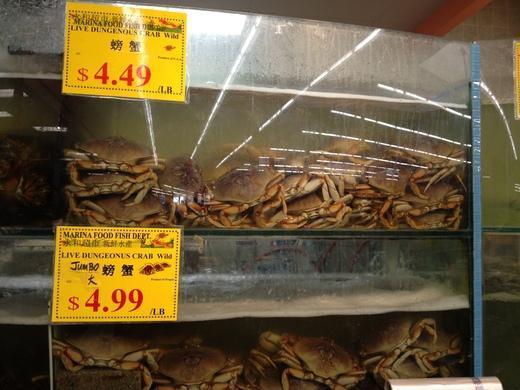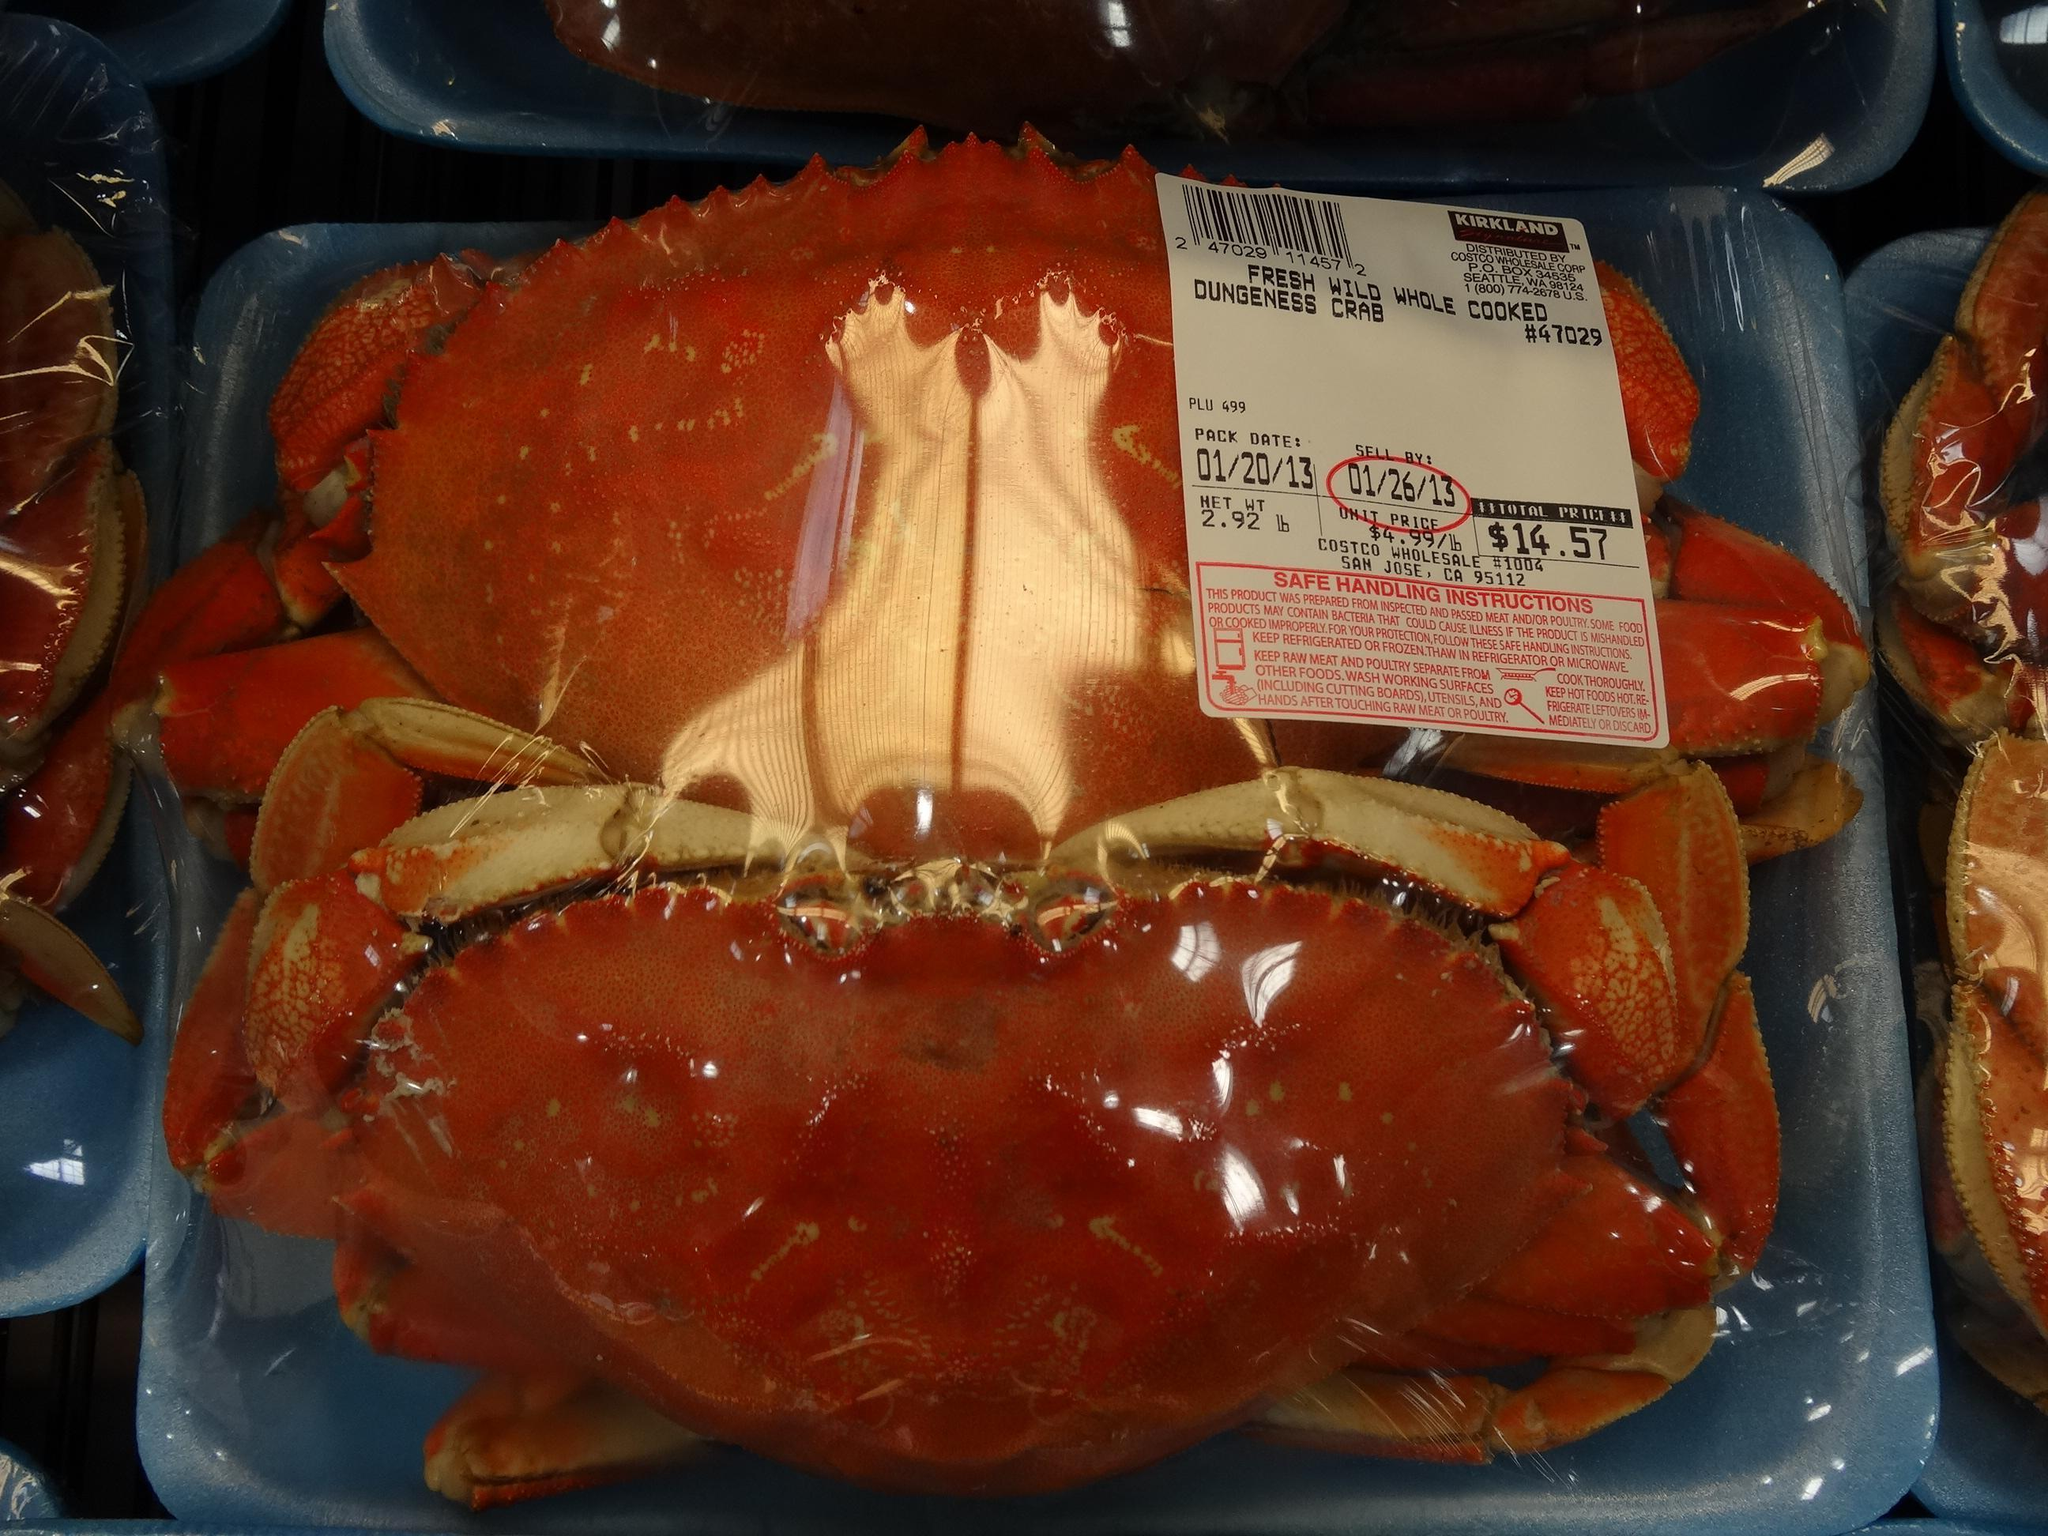The first image is the image on the left, the second image is the image on the right. For the images displayed, is the sentence "All the crabs are piled on top of one another." factually correct? Answer yes or no. No. The first image is the image on the left, the second image is the image on the right. Evaluate the accuracy of this statement regarding the images: "In the right image, a white rectangular label is overlapping a red-orange-shelled crab that is in some type of container.". Is it true? Answer yes or no. Yes. 